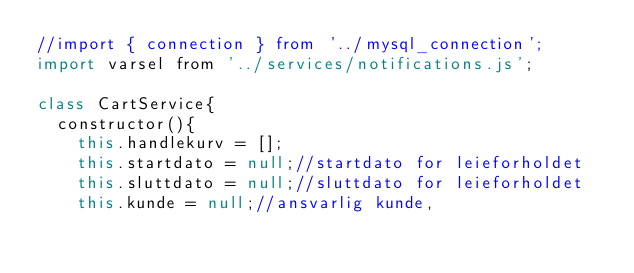<code> <loc_0><loc_0><loc_500><loc_500><_JavaScript_>//import { connection } from '../mysql_connection';
import varsel from '../services/notifications.js';

class CartService{
  constructor(){
    this.handlekurv = [];
    this.startdato = null;//startdato for leieforholdet
    this.sluttdato = null;//sluttdato for leieforholdet
    this.kunde = null;//ansvarlig kunde,</code> 